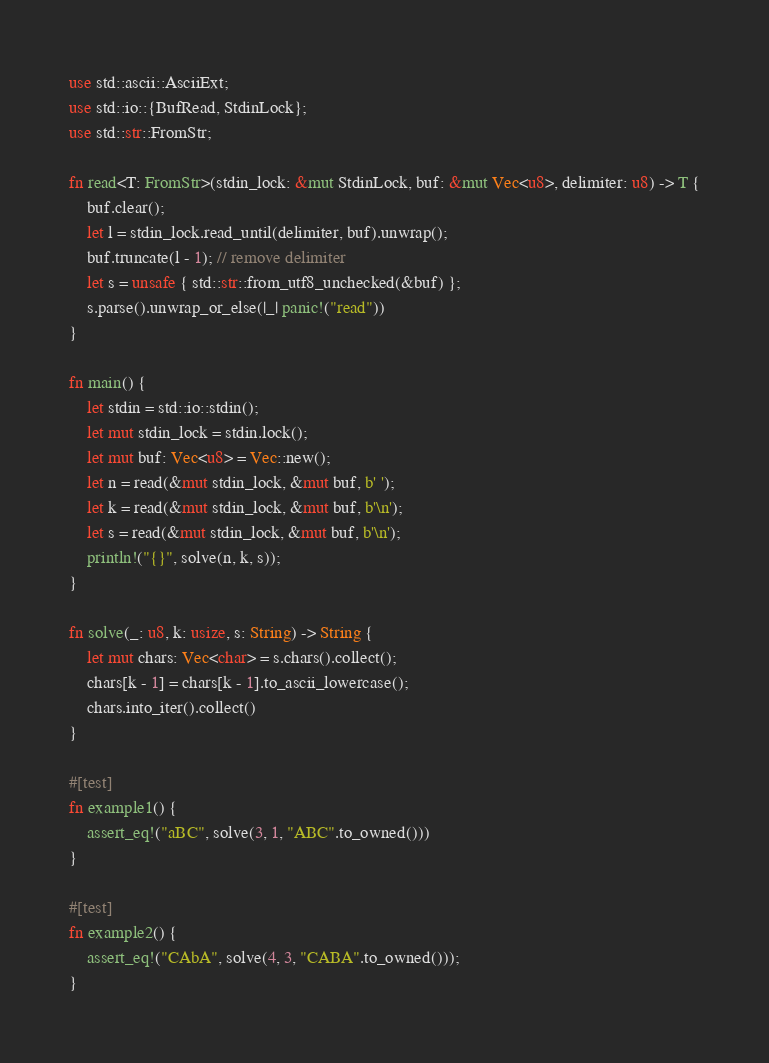Convert code to text. <code><loc_0><loc_0><loc_500><loc_500><_Rust_>use std::ascii::AsciiExt;
use std::io::{BufRead, StdinLock};
use std::str::FromStr;

fn read<T: FromStr>(stdin_lock: &mut StdinLock, buf: &mut Vec<u8>, delimiter: u8) -> T {
    buf.clear();
    let l = stdin_lock.read_until(delimiter, buf).unwrap();
    buf.truncate(l - 1); // remove delimiter
    let s = unsafe { std::str::from_utf8_unchecked(&buf) };
    s.parse().unwrap_or_else(|_| panic!("read"))
}

fn main() {
    let stdin = std::io::stdin();
    let mut stdin_lock = stdin.lock();
    let mut buf: Vec<u8> = Vec::new();
    let n = read(&mut stdin_lock, &mut buf, b' ');
    let k = read(&mut stdin_lock, &mut buf, b'\n');
    let s = read(&mut stdin_lock, &mut buf, b'\n');
    println!("{}", solve(n, k, s));
}

fn solve(_: u8, k: usize, s: String) -> String {
    let mut chars: Vec<char> = s.chars().collect();
    chars[k - 1] = chars[k - 1].to_ascii_lowercase();
    chars.into_iter().collect()
}

#[test]
fn example1() {
    assert_eq!("aBC", solve(3, 1, "ABC".to_owned()))
}

#[test]
fn example2() {
    assert_eq!("CAbA", solve(4, 3, "CABA".to_owned()));
}
</code> 